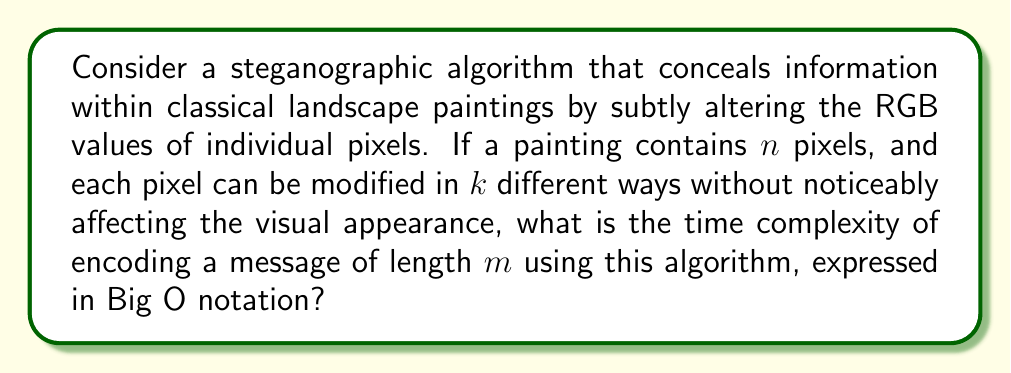Show me your answer to this math problem. To solve this problem, let's break it down step-by-step:

1) First, we need to understand what the algorithm does. It modifies individual pixels in the painting to encode the message.

2) For each character in the message (length $m$), the algorithm needs to:
   a) Choose a pixel to modify
   b) Decide how to modify it (from $k$ options)

3) Choosing a pixel:
   - In the worst case, this might require scanning all $n$ pixels to find a suitable one.
   - Time complexity: $O(n)$

4) Modifying the pixel:
   - This involves choosing from $k$ options, which is a constant time operation.
   - Time complexity: $O(1)$

5) These operations are performed for each of the $m$ characters in the message.

6) Therefore, the total time complexity is:
   $$O(m \cdot (n + 1)) = O(mn + m)$$

7) In Big O notation, we focus on the dominant term as the input size grows. Since $n$ (number of pixels) is typically much larger than $m$ (message length) in a classical painting, $mn$ dominates $m$.

8) Thus, we can simplify the expression to:
   $$O(mn)$$

This complexity suggests that the time taken by the algorithm grows linearly with both the size of the painting and the length of the message.
Answer: $O(mn)$ 